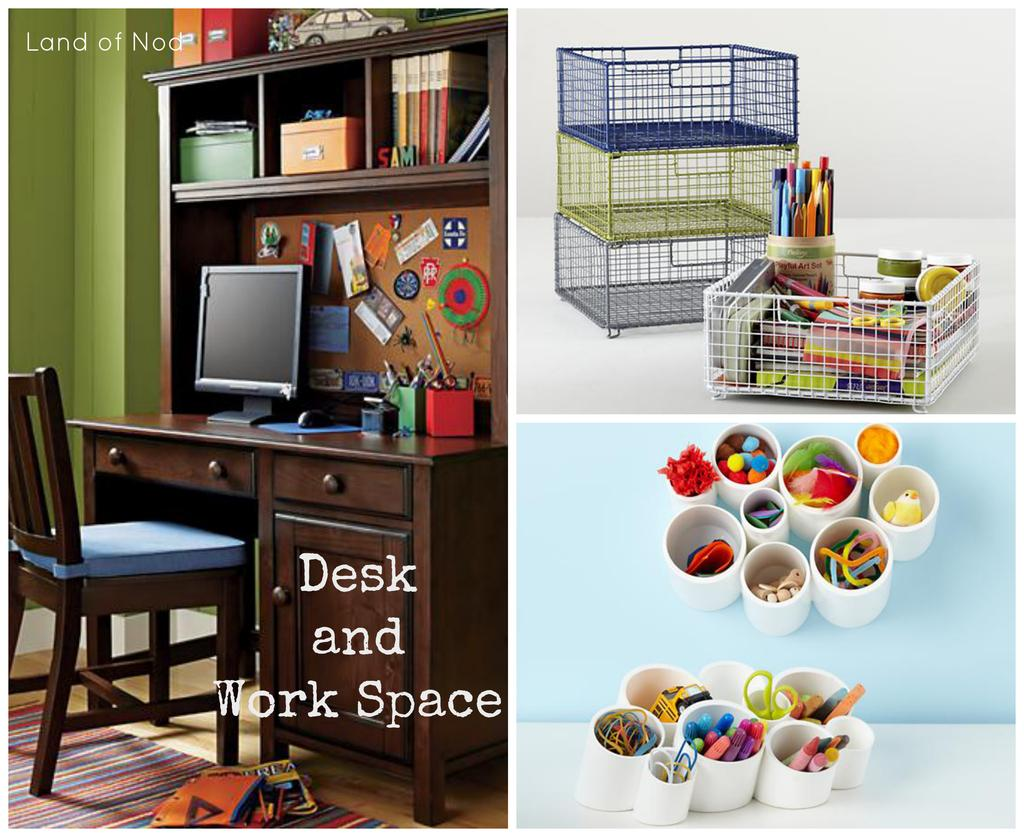<image>
Give a short and clear explanation of the subsequent image. An advertisement for a desk and work space is labeled with Land of Nod at the top. 